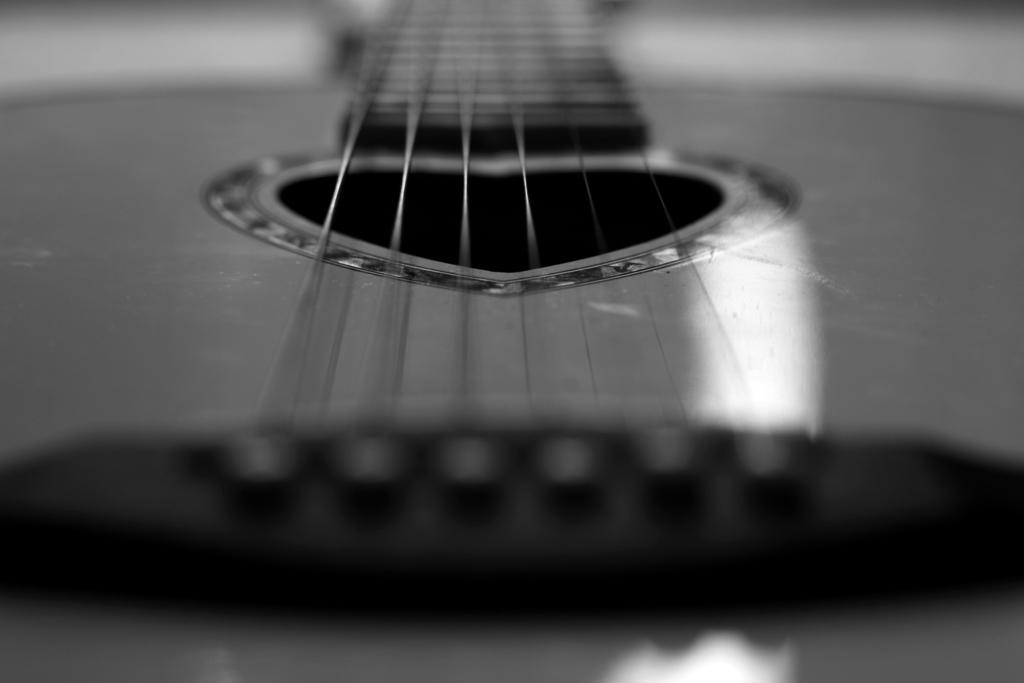What is the color scheme of the image? The image is black and white. What musical instrument can be seen in the image? There are strings of a guitar visible in the image. Can you see a pot on the seashore in the image? There is no pot or seashore present in the image; it features a guitar with strings. 